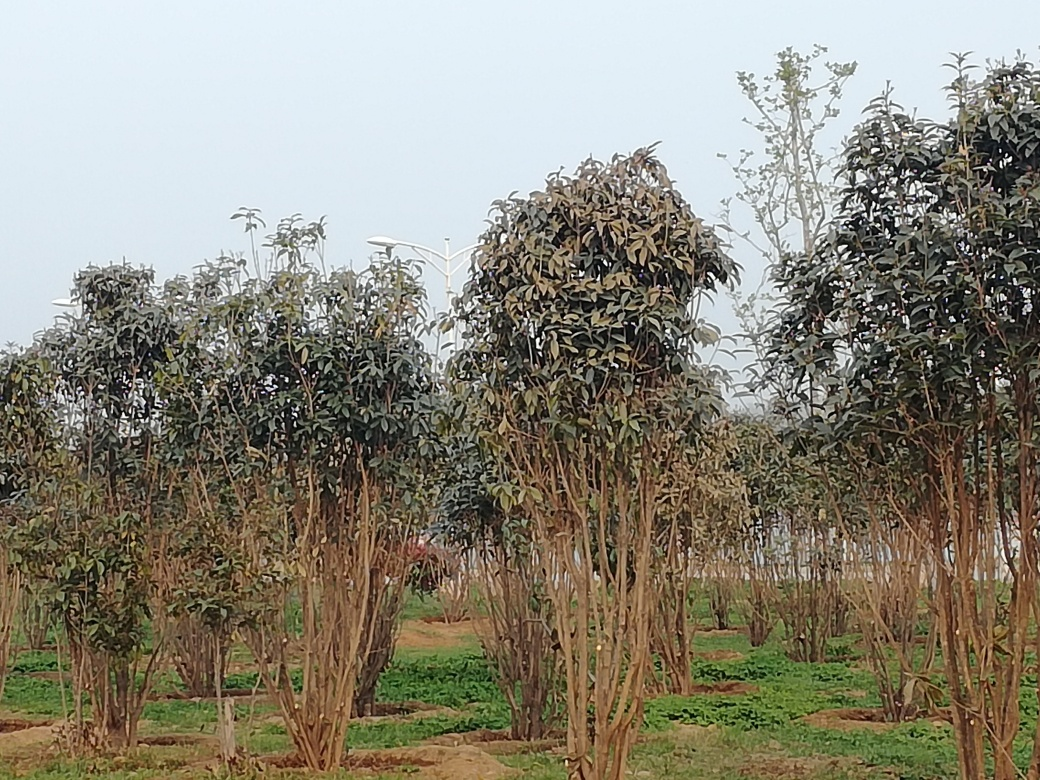Is the composition of the image acceptable? The composition of the image is moderate, with a good distribution of trees across the frame. However, to improve the composition, one could adhere to the 'rule of thirds' by positioning key elements along the lines or their intersections or adjusting the angle to reduce the amount of empty sky and highlight the landscape more dynamically. 